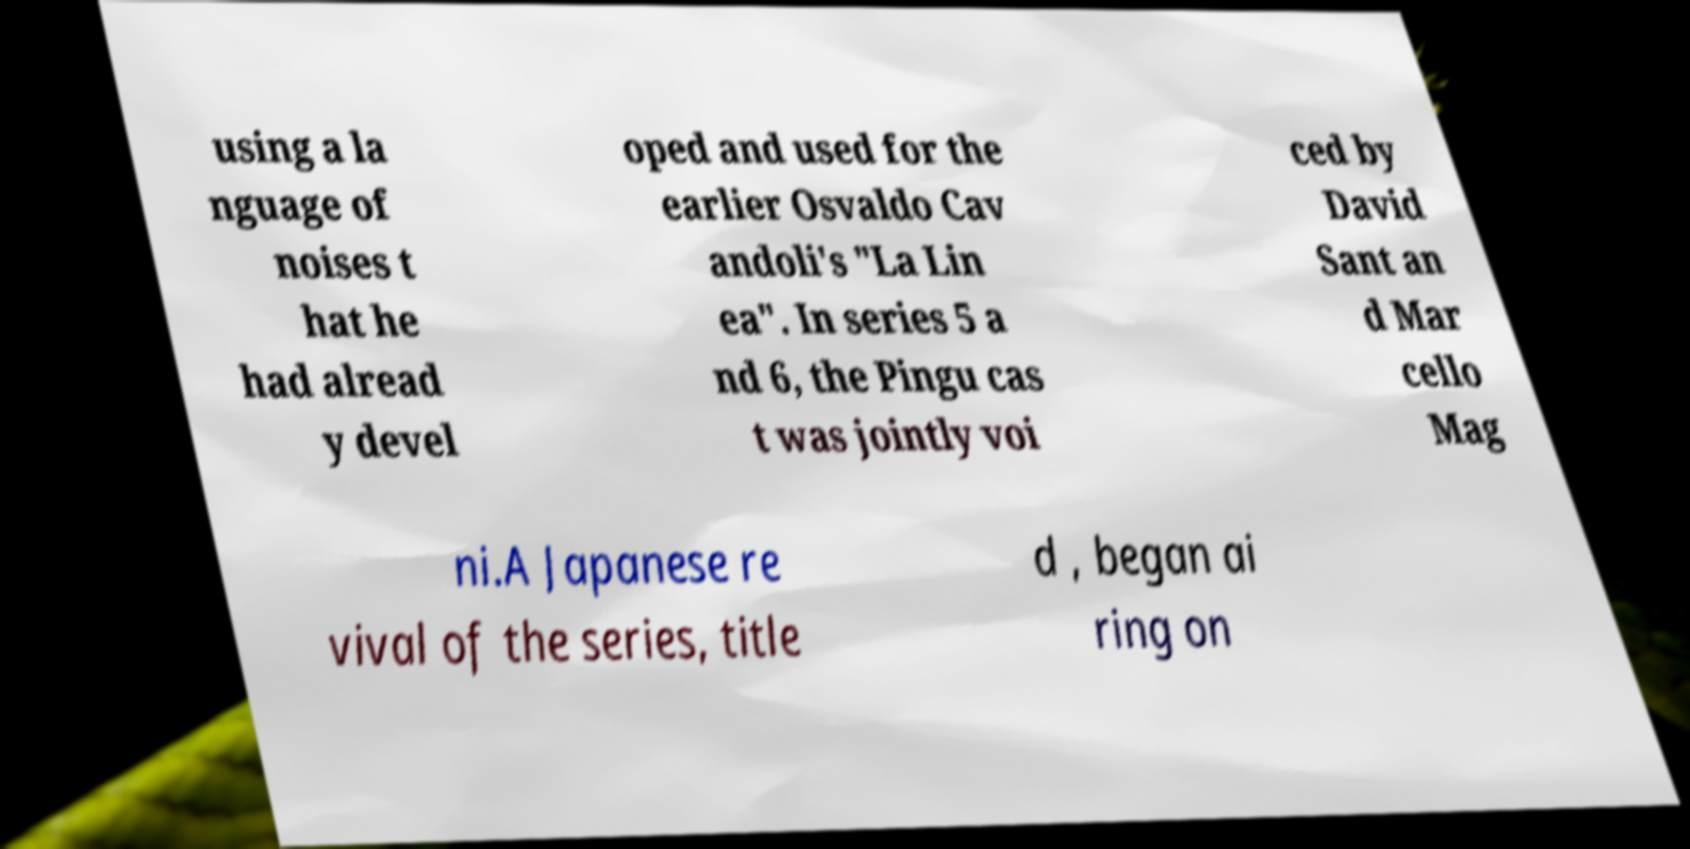Could you assist in decoding the text presented in this image and type it out clearly? using a la nguage of noises t hat he had alread y devel oped and used for the earlier Osvaldo Cav andoli's "La Lin ea". In series 5 a nd 6, the Pingu cas t was jointly voi ced by David Sant an d Mar cello Mag ni.A Japanese re vival of the series, title d , began ai ring on 